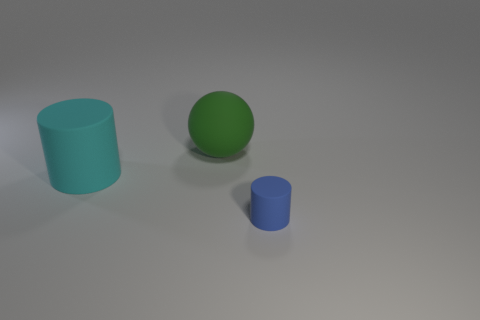What is the shape of the cyan object that is the same size as the green thing? cylinder 